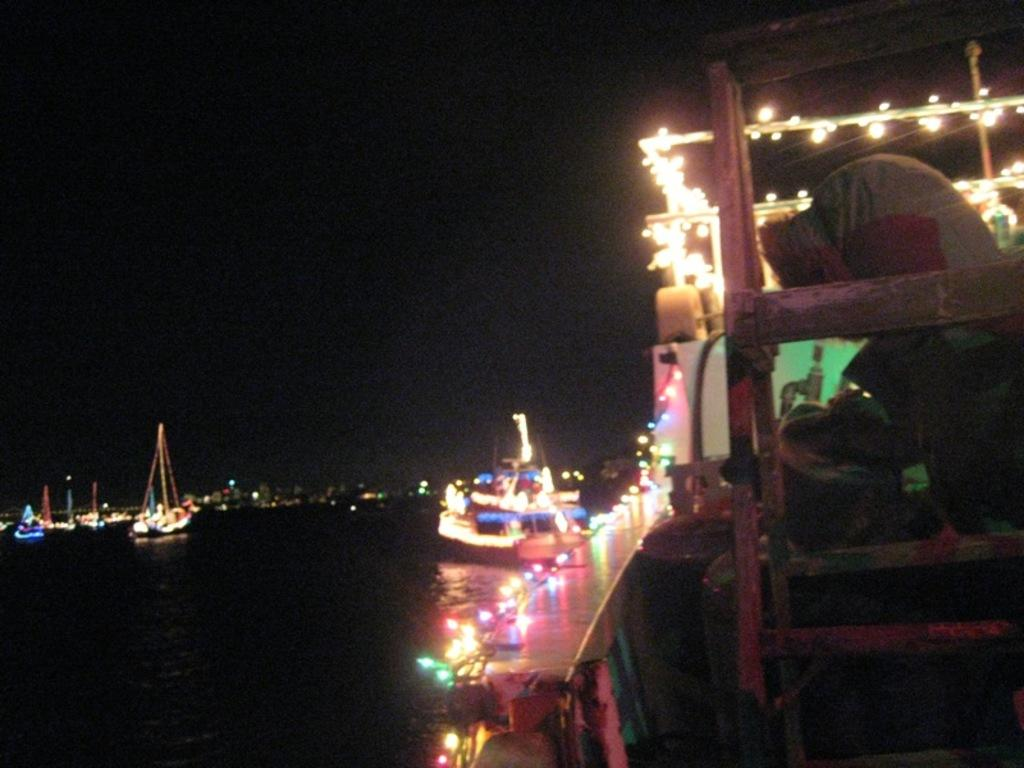What types of watercraft are visible in the image? There are ships and boats in the image. Can you describe the person in the image? There is a person to the right in the image. What is the primary setting of the image? There is water at the bottom of the image and a sky at the top of the image. What type of band is playing in the image? There is no band present in the image. What is the person in the image afraid of? There is no indication of fear in the image, and we cannot assume the person's emotions based on the image alone. 